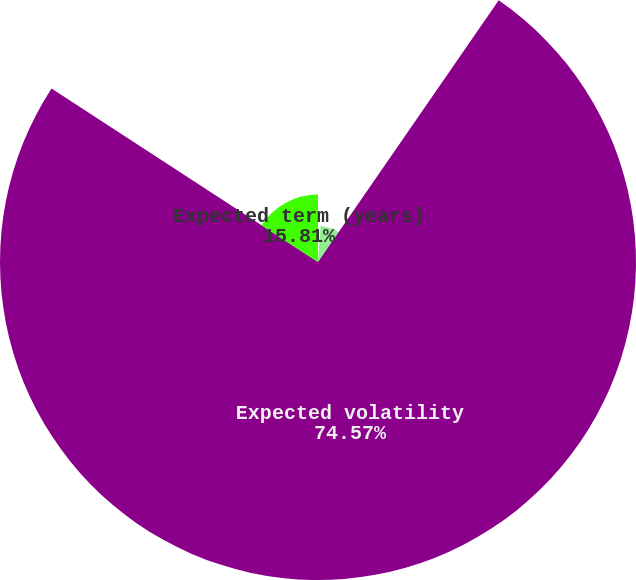Convert chart to OTSL. <chart><loc_0><loc_0><loc_500><loc_500><pie_chart><fcel>Average risk-free interest<fcel>Expected dividend yield<fcel>Expected volatility<fcel>Expected term (years)<nl><fcel>1.14%<fcel>8.48%<fcel>74.56%<fcel>15.81%<nl></chart> 